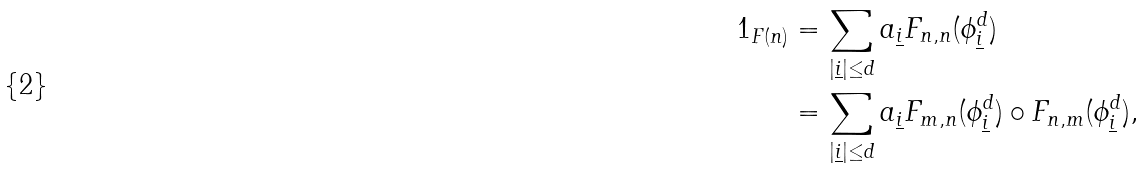Convert formula to latex. <formula><loc_0><loc_0><loc_500><loc_500>1 _ { F ( n ) } & = \sum _ { | \underline { i } | \leq d } a _ { \underline { i } } F _ { n , n } ( \phi _ { \underline { i } } ^ { d } ) \\ & = \sum _ { | \underline { i } | \leq d } a _ { \underline { i } } F _ { m , n } ( \phi _ { \underline { i } } ^ { d } ) \circ F _ { n , m } ( \phi _ { \underline { i } } ^ { d } ) ,</formula> 